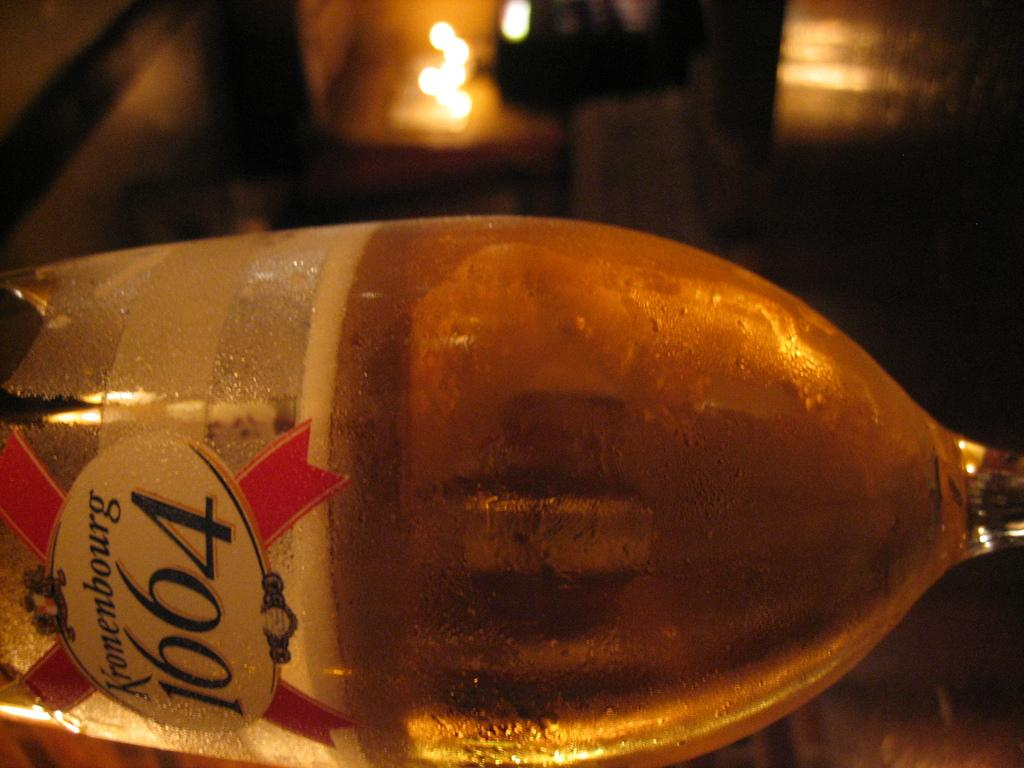<image>
Present a compact description of the photo's key features. Kronembourg 1664 Wine, which has a brown color with a red x logo on it. 